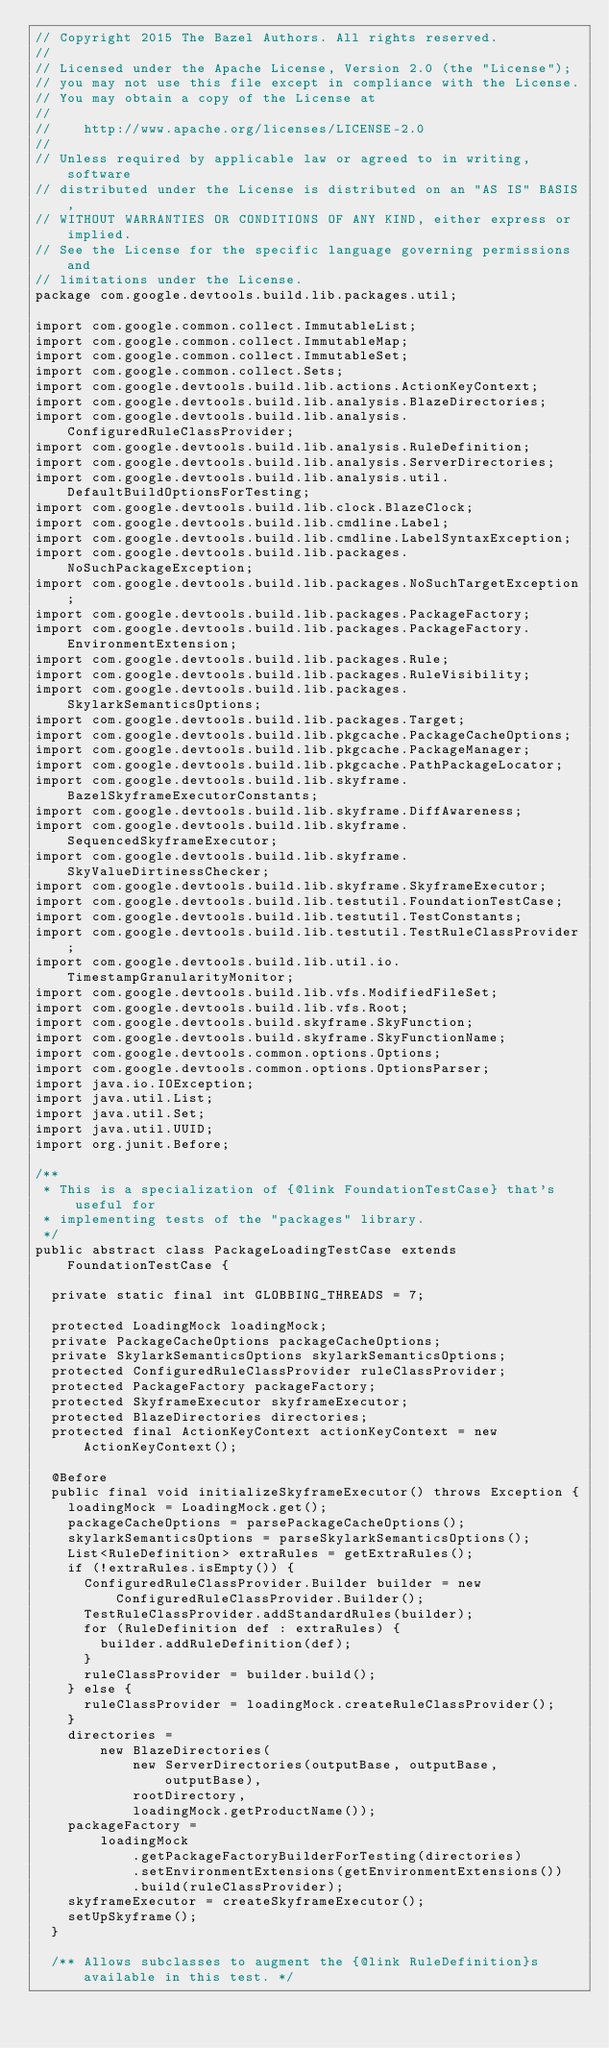Convert code to text. <code><loc_0><loc_0><loc_500><loc_500><_Java_>// Copyright 2015 The Bazel Authors. All rights reserved.
//
// Licensed under the Apache License, Version 2.0 (the "License");
// you may not use this file except in compliance with the License.
// You may obtain a copy of the License at
//
//    http://www.apache.org/licenses/LICENSE-2.0
//
// Unless required by applicable law or agreed to in writing, software
// distributed under the License is distributed on an "AS IS" BASIS,
// WITHOUT WARRANTIES OR CONDITIONS OF ANY KIND, either express or implied.
// See the License for the specific language governing permissions and
// limitations under the License.
package com.google.devtools.build.lib.packages.util;

import com.google.common.collect.ImmutableList;
import com.google.common.collect.ImmutableMap;
import com.google.common.collect.ImmutableSet;
import com.google.common.collect.Sets;
import com.google.devtools.build.lib.actions.ActionKeyContext;
import com.google.devtools.build.lib.analysis.BlazeDirectories;
import com.google.devtools.build.lib.analysis.ConfiguredRuleClassProvider;
import com.google.devtools.build.lib.analysis.RuleDefinition;
import com.google.devtools.build.lib.analysis.ServerDirectories;
import com.google.devtools.build.lib.analysis.util.DefaultBuildOptionsForTesting;
import com.google.devtools.build.lib.clock.BlazeClock;
import com.google.devtools.build.lib.cmdline.Label;
import com.google.devtools.build.lib.cmdline.LabelSyntaxException;
import com.google.devtools.build.lib.packages.NoSuchPackageException;
import com.google.devtools.build.lib.packages.NoSuchTargetException;
import com.google.devtools.build.lib.packages.PackageFactory;
import com.google.devtools.build.lib.packages.PackageFactory.EnvironmentExtension;
import com.google.devtools.build.lib.packages.Rule;
import com.google.devtools.build.lib.packages.RuleVisibility;
import com.google.devtools.build.lib.packages.SkylarkSemanticsOptions;
import com.google.devtools.build.lib.packages.Target;
import com.google.devtools.build.lib.pkgcache.PackageCacheOptions;
import com.google.devtools.build.lib.pkgcache.PackageManager;
import com.google.devtools.build.lib.pkgcache.PathPackageLocator;
import com.google.devtools.build.lib.skyframe.BazelSkyframeExecutorConstants;
import com.google.devtools.build.lib.skyframe.DiffAwareness;
import com.google.devtools.build.lib.skyframe.SequencedSkyframeExecutor;
import com.google.devtools.build.lib.skyframe.SkyValueDirtinessChecker;
import com.google.devtools.build.lib.skyframe.SkyframeExecutor;
import com.google.devtools.build.lib.testutil.FoundationTestCase;
import com.google.devtools.build.lib.testutil.TestConstants;
import com.google.devtools.build.lib.testutil.TestRuleClassProvider;
import com.google.devtools.build.lib.util.io.TimestampGranularityMonitor;
import com.google.devtools.build.lib.vfs.ModifiedFileSet;
import com.google.devtools.build.lib.vfs.Root;
import com.google.devtools.build.skyframe.SkyFunction;
import com.google.devtools.build.skyframe.SkyFunctionName;
import com.google.devtools.common.options.Options;
import com.google.devtools.common.options.OptionsParser;
import java.io.IOException;
import java.util.List;
import java.util.Set;
import java.util.UUID;
import org.junit.Before;

/**
 * This is a specialization of {@link FoundationTestCase} that's useful for
 * implementing tests of the "packages" library.
 */
public abstract class PackageLoadingTestCase extends FoundationTestCase {

  private static final int GLOBBING_THREADS = 7;

  protected LoadingMock loadingMock;
  private PackageCacheOptions packageCacheOptions;
  private SkylarkSemanticsOptions skylarkSemanticsOptions;
  protected ConfiguredRuleClassProvider ruleClassProvider;
  protected PackageFactory packageFactory;
  protected SkyframeExecutor skyframeExecutor;
  protected BlazeDirectories directories;
  protected final ActionKeyContext actionKeyContext = new ActionKeyContext();

  @Before
  public final void initializeSkyframeExecutor() throws Exception {
    loadingMock = LoadingMock.get();
    packageCacheOptions = parsePackageCacheOptions();
    skylarkSemanticsOptions = parseSkylarkSemanticsOptions();
    List<RuleDefinition> extraRules = getExtraRules();
    if (!extraRules.isEmpty()) {
      ConfiguredRuleClassProvider.Builder builder = new ConfiguredRuleClassProvider.Builder();
      TestRuleClassProvider.addStandardRules(builder);
      for (RuleDefinition def : extraRules) {
        builder.addRuleDefinition(def);
      }
      ruleClassProvider = builder.build();
    } else {
      ruleClassProvider = loadingMock.createRuleClassProvider();
    }
    directories =
        new BlazeDirectories(
            new ServerDirectories(outputBase, outputBase, outputBase),
            rootDirectory,
            loadingMock.getProductName());
    packageFactory =
        loadingMock
            .getPackageFactoryBuilderForTesting(directories)
            .setEnvironmentExtensions(getEnvironmentExtensions())
            .build(ruleClassProvider);
    skyframeExecutor = createSkyframeExecutor();
    setUpSkyframe();
  }

  /** Allows subclasses to augment the {@link RuleDefinition}s available in this test. */</code> 